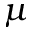Convert formula to latex. <formula><loc_0><loc_0><loc_500><loc_500>\mu</formula> 